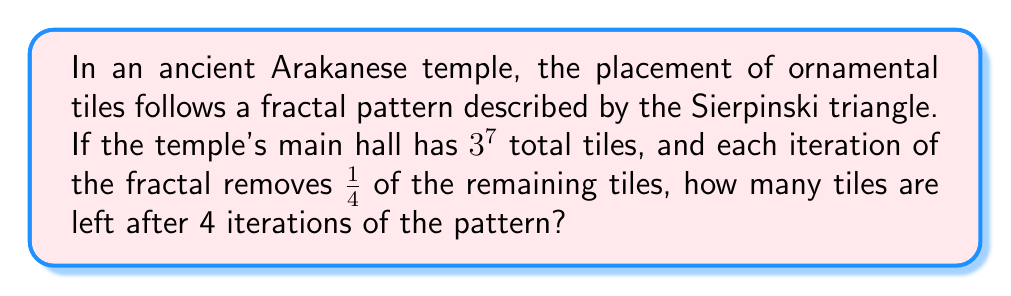Can you answer this question? Let's approach this step-by-step:

1) First, we need to calculate the initial number of tiles:
   $$3^7 = 3 \times 3 \times 3 \times 3 \times 3 \times 3 \times 3 = 2187$$ tiles

2) In each iteration, 3/4 of the tiles remain (as 1/4 are removed).
   We can represent this as a multiplication by 3/4 or 0.75.

3) After 4 iterations, the number of remaining tiles will be:
   $$2187 \times (3/4)^4$$

4) Let's calculate $(3/4)^4$:
   $$(3/4)^4 = (3/4) \times (3/4) \times (3/4) \times (3/4) = 81/256 = 0.31640625$$

5) Now, let's multiply this by our initial number of tiles:
   $$2187 \times 0.31640625 = 691.9921875$$

6) Since we can't have a fractional number of tiles, we round down to the nearest whole number.
Answer: 691 tiles 